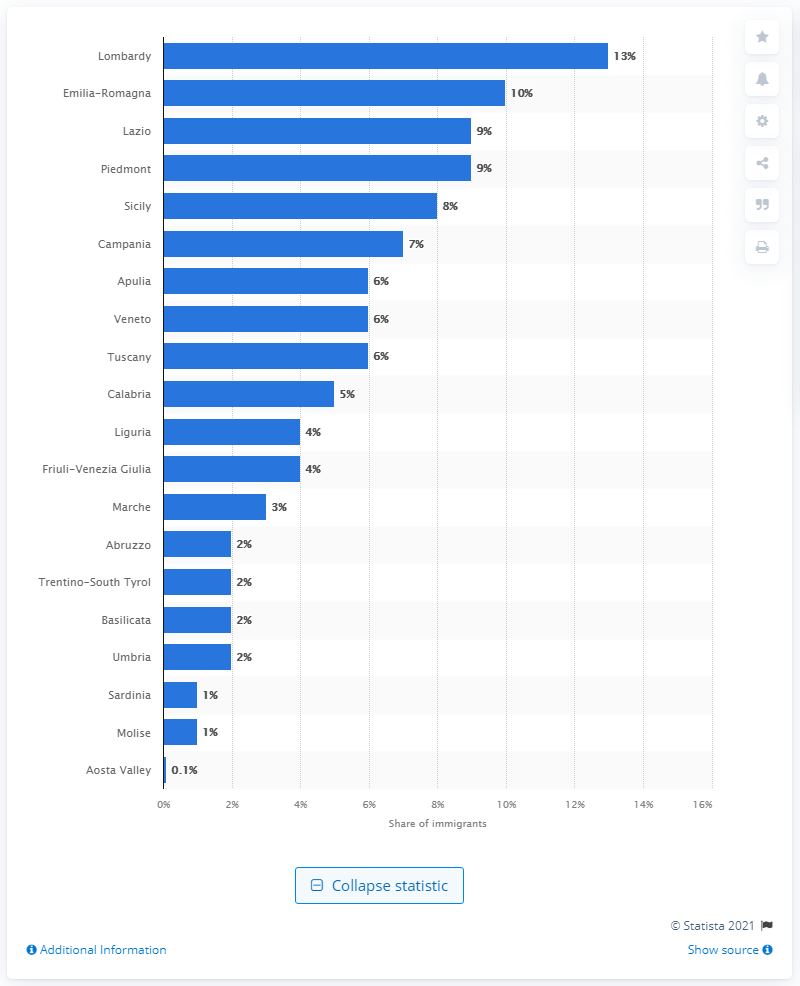Give some essential details in this illustration. As of May 2021, the percentage of immigrants in Lombardy was 13%. As of May 2021, the largest share of immigrants in the region of Italy was located in Lombardy. 